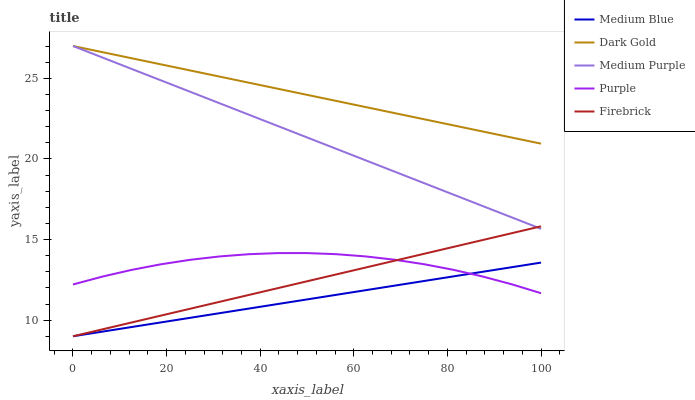Does Medium Blue have the minimum area under the curve?
Answer yes or no. Yes. Does Purple have the minimum area under the curve?
Answer yes or no. No. Does Purple have the maximum area under the curve?
Answer yes or no. No. Is Purple the roughest?
Answer yes or no. Yes. Is Purple the smoothest?
Answer yes or no. No. Is Firebrick the roughest?
Answer yes or no. No. Does Purple have the lowest value?
Answer yes or no. No. Does Purple have the highest value?
Answer yes or no. No. Is Medium Blue less than Medium Purple?
Answer yes or no. Yes. Is Medium Purple greater than Purple?
Answer yes or no. Yes. Does Medium Blue intersect Medium Purple?
Answer yes or no. No. 